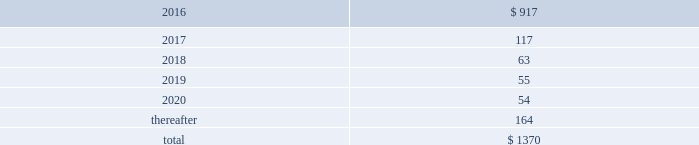Guarantees and warranties in april 2015 , we entered into joint venture arrangements in saudi arabia .
An equity bridge loan has been provided to the joint venture until 2020 to fund equity commitments , and we guaranteed the repayment of our 25% ( 25 % ) share of this loan .
Our venture partner guaranteed repayment of their share .
Our maximum exposure under the guarantee is approximately $ 100 .
As of 30 september 2015 , we recorded a noncurrent liability of $ 67.5 for our obligation to make future equity contributions based on the equity bridge loan .
Air products has also entered into a sale of equipment contract with the joint venture to engineer , procure , and construct the industrial gas facilities that will supply gases to saudi aramco .
We will provide bank guarantees to the joint venture of up to $ 326 to support our performance under the contract .
We are party to an equity support agreement and operations guarantee related to an air separation facility constructed in trinidad for a venture in which we own 50% ( 50 % ) .
At 30 september 2015 , maximum potential payments under joint and several guarantees were $ 30.0 .
Exposures under the guarantee decline over time and will be completely extinguished by 2024 .
During the first quarter of 2014 , we sold the remaining portion of our homecare business and entered into an operations guarantee related to obligations under certain homecare contracts assigned in connection with the transaction .
Our maximum potential payment under the guarantee is a320 million ( approximately $ 30 at 30 september 2015 ) , and our exposure will be extinguished by 2020 .
To date , no equity contributions or payments have been made since the inception of these guarantees .
The fair value of the above guarantees is not material .
We , in the normal course of business operations , have issued product warranties related to equipment sales .
Also , contracts often contain standard terms and conditions which typically include a warranty and indemnification to the buyer that the goods and services purchased do not infringe on third-party intellectual property rights .
The provision for estimated future costs relating to warranties is not material to the consolidated financial statements .
We do not expect that any sum we may have to pay in connection with guarantees and warranties will have a material adverse effect on our consolidated financial condition , liquidity , or results of operations .
Unconditional purchase obligations we are obligated to make future payments under unconditional purchase obligations as summarized below: .
Approximately $ 390 of our long-term unconditional purchase obligations relate to feedstock supply for numerous hyco ( hydrogen , carbon monoxide , and syngas ) facilities .
The price of feedstock supply is principally related to the price of natural gas .
However , long-term take-or-pay sales contracts to hyco customers are generally matched to the term of the feedstock supply obligations and provide recovery of price increases in the feedstock supply .
Due to the matching of most long-term feedstock supply obligations to customer sales contracts , we do not believe these purchase obligations would have a material effect on our financial condition or results of operations .
The unconditional purchase obligations also include other product supply and purchase commitments and electric power and natural gas supply purchase obligations , which are primarily pass-through contracts with our customers .
Purchase commitments to spend approximately $ 540 for additional plant and equipment are included in the unconditional purchase obligations in 2016. .
What was the decrease observed in the unconditional purchase obligations during 2016 and 2017? 
Rationale: it is the percentual variation observed during these years , which is calculated by subtracting the initial value ( 2016 ) of the final one ( 2017 ) then dividing by the initial and turned into a percentage .
Computations: ((117 - 917) / 917)
Answer: -0.87241. 